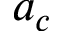<formula> <loc_0><loc_0><loc_500><loc_500>a _ { c }</formula> 